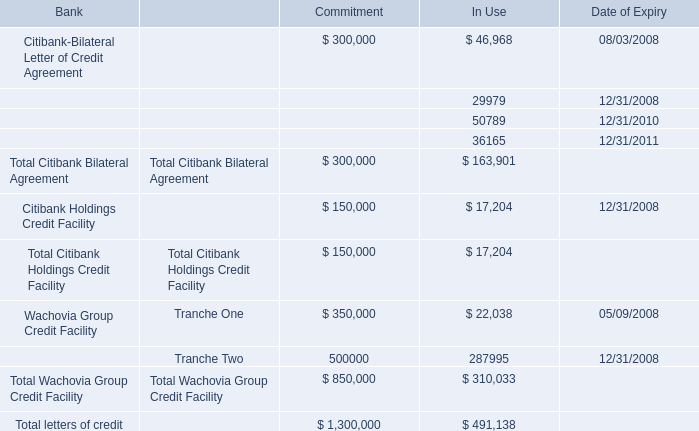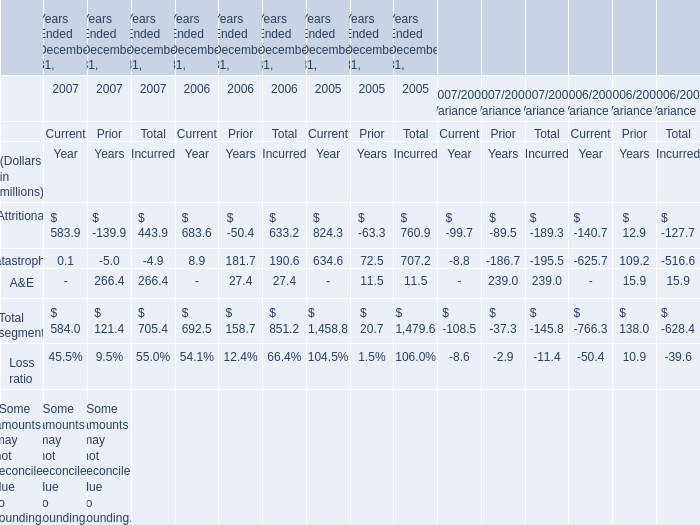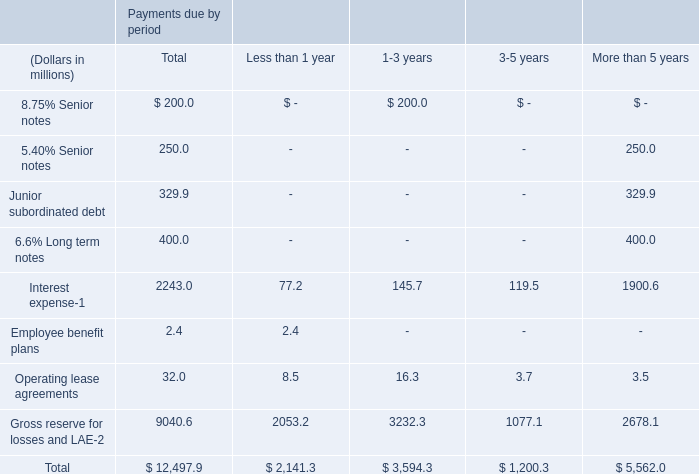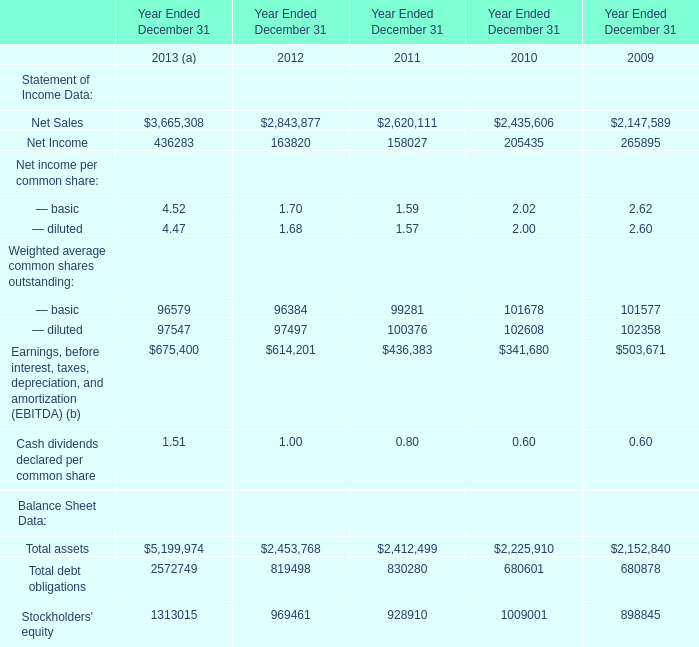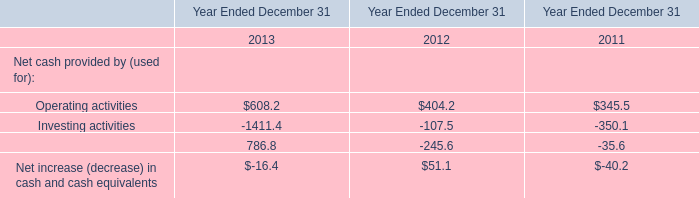In the year with the most Net Sales in Table 0, what is the growth rate of Operating activities in Table 1? 
Computations: ((608.2 - 404.2) / 404.2)
Answer: 0.5047. 